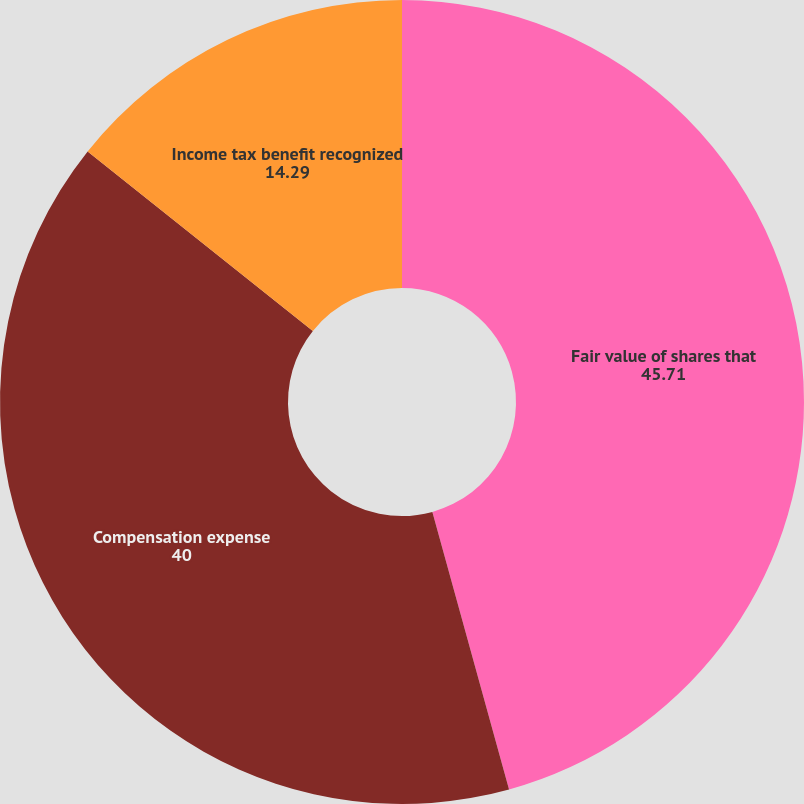Convert chart to OTSL. <chart><loc_0><loc_0><loc_500><loc_500><pie_chart><fcel>Fair value of shares that<fcel>Compensation expense<fcel>Income tax benefit recognized<nl><fcel>45.71%<fcel>40.0%<fcel>14.29%<nl></chart> 